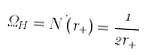<formula> <loc_0><loc_0><loc_500><loc_500>\Omega _ { H } = N ^ { \varphi } ( r _ { + } ) = \frac { 1 } { 2 r _ { + } }</formula> 